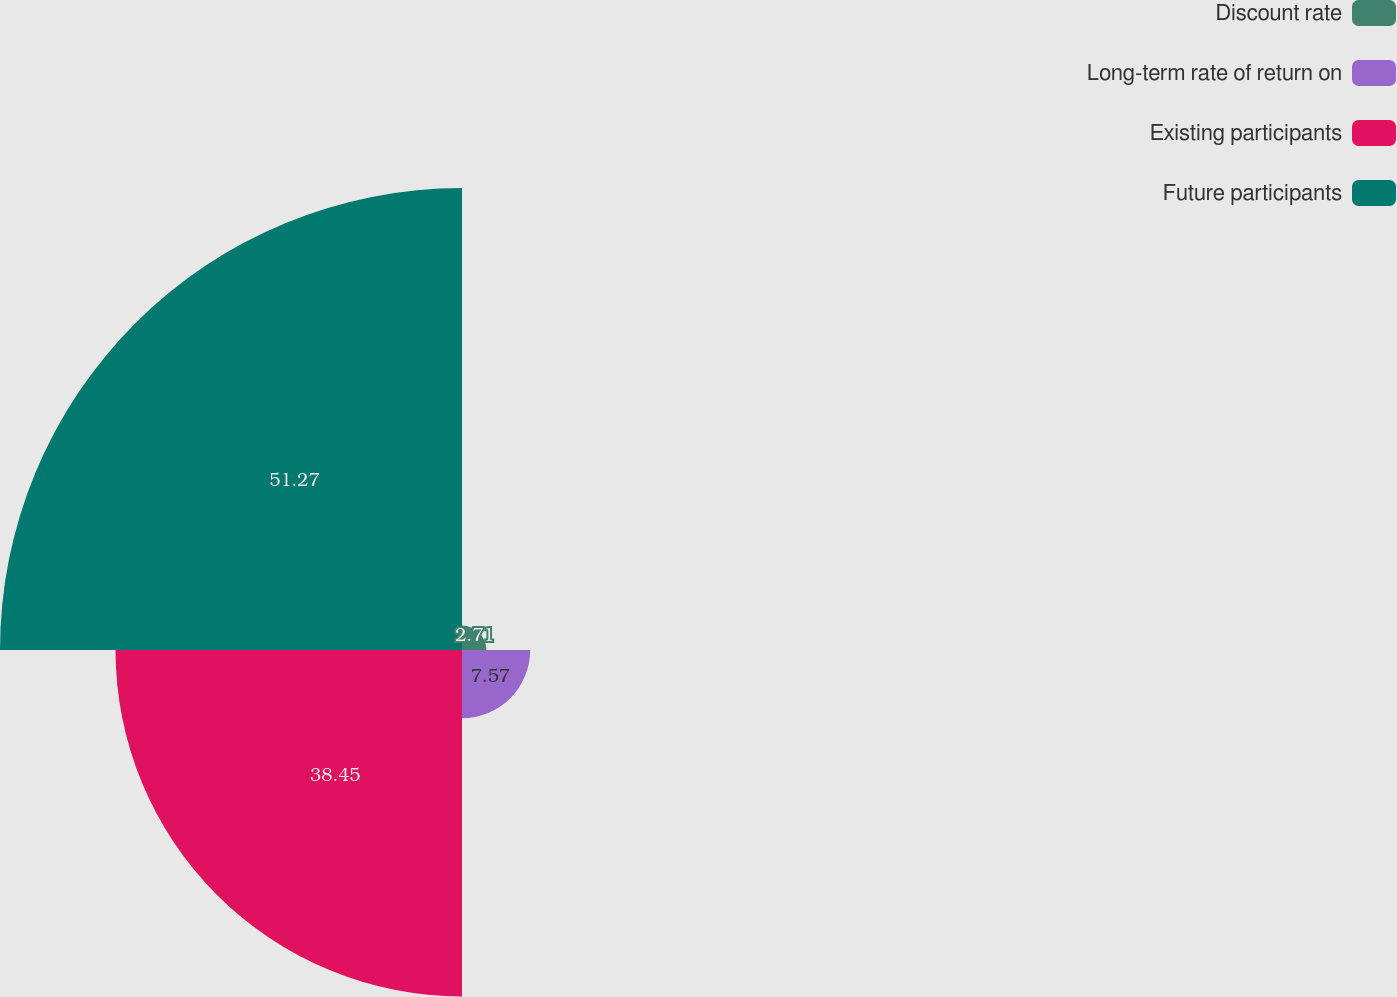Convert chart. <chart><loc_0><loc_0><loc_500><loc_500><pie_chart><fcel>Discount rate<fcel>Long-term rate of return on<fcel>Existing participants<fcel>Future participants<nl><fcel>2.71%<fcel>7.57%<fcel>38.45%<fcel>51.27%<nl></chart> 